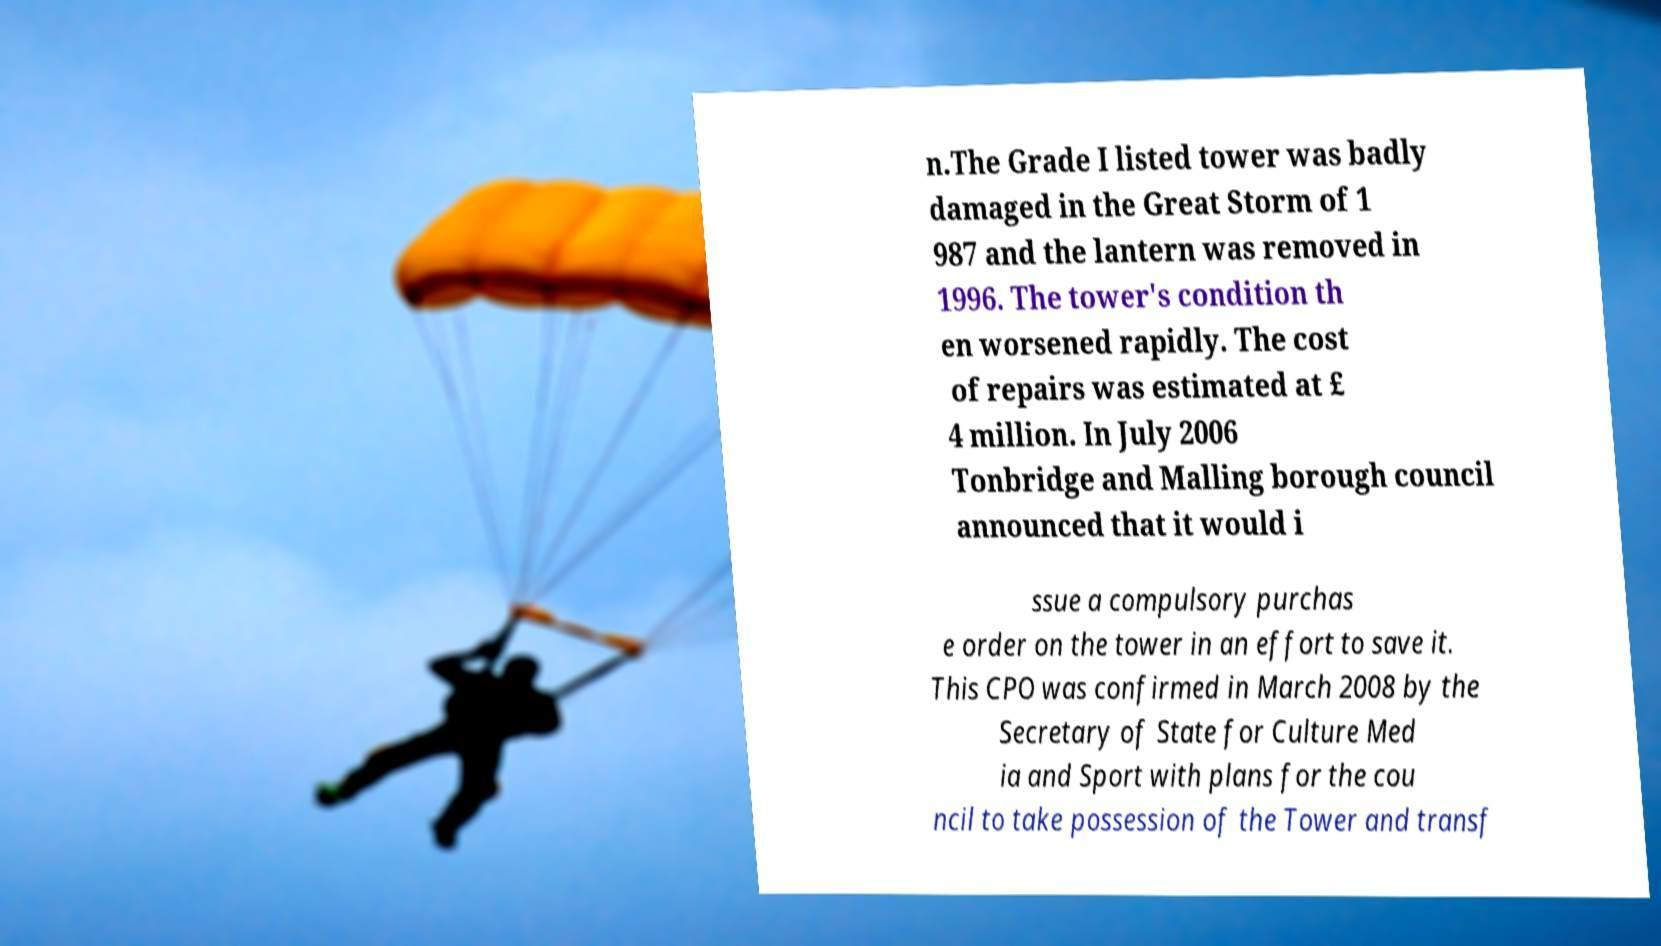There's text embedded in this image that I need extracted. Can you transcribe it verbatim? n.The Grade I listed tower was badly damaged in the Great Storm of 1 987 and the lantern was removed in 1996. The tower's condition th en worsened rapidly. The cost of repairs was estimated at £ 4 million. In July 2006 Tonbridge and Malling borough council announced that it would i ssue a compulsory purchas e order on the tower in an effort to save it. This CPO was confirmed in March 2008 by the Secretary of State for Culture Med ia and Sport with plans for the cou ncil to take possession of the Tower and transf 